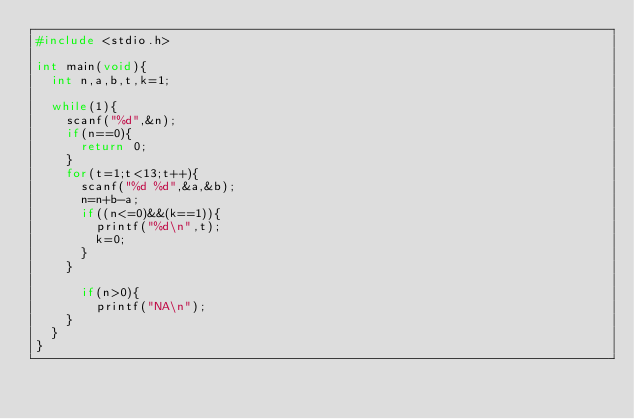Convert code to text. <code><loc_0><loc_0><loc_500><loc_500><_C_>#include <stdio.h>

int main(void){
	int n,a,b,t,k=1;
	
	while(1){
		scanf("%d",&n);
		if(n==0){
			return 0;
		}
		for(t=1;t<13;t++){
			scanf("%d %d",&a,&b);
			n=n+b-a;
			if((n<=0)&&(k==1)){
				printf("%d\n",t);
				k=0;
			}
		}
		
			if(n>0){
				printf("NA\n");
		}
	}
}</code> 